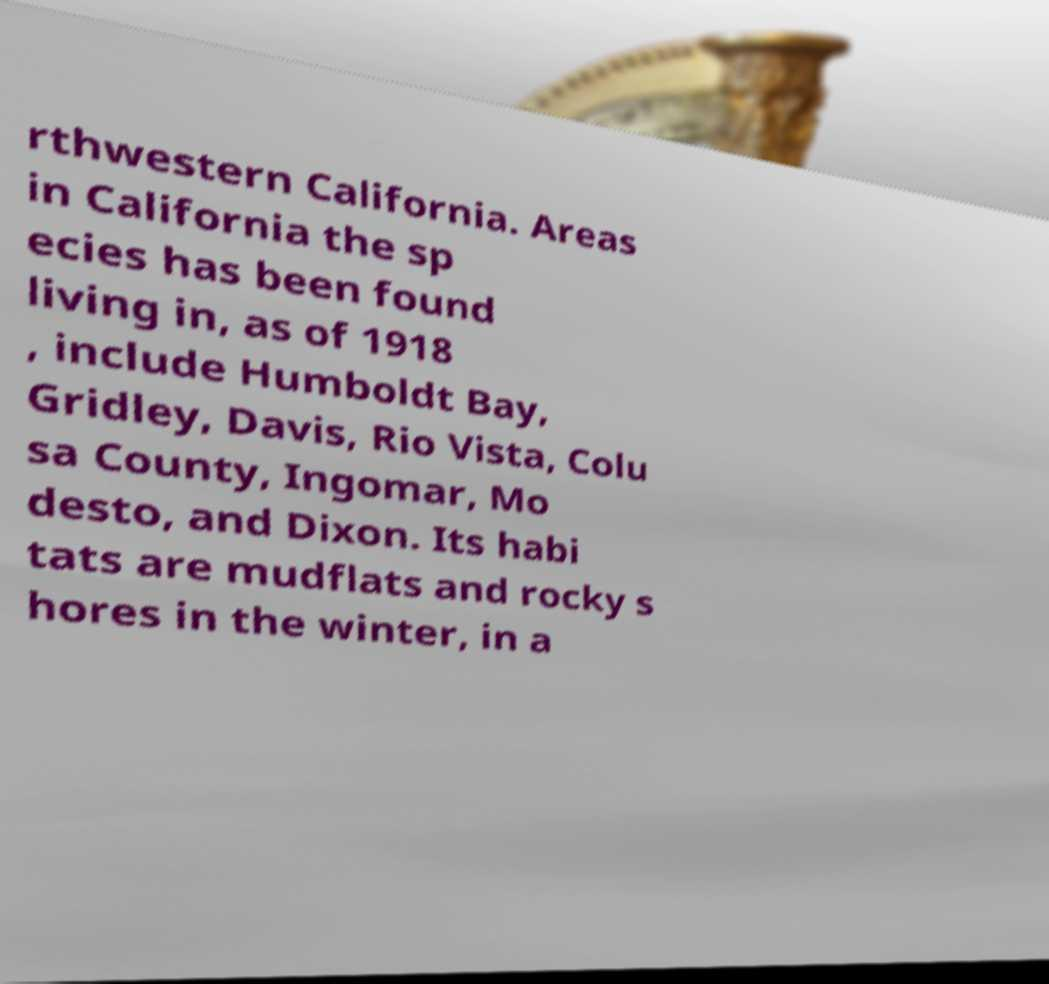There's text embedded in this image that I need extracted. Can you transcribe it verbatim? rthwestern California. Areas in California the sp ecies has been found living in, as of 1918 , include Humboldt Bay, Gridley, Davis, Rio Vista, Colu sa County, Ingomar, Mo desto, and Dixon. Its habi tats are mudflats and rocky s hores in the winter, in a 